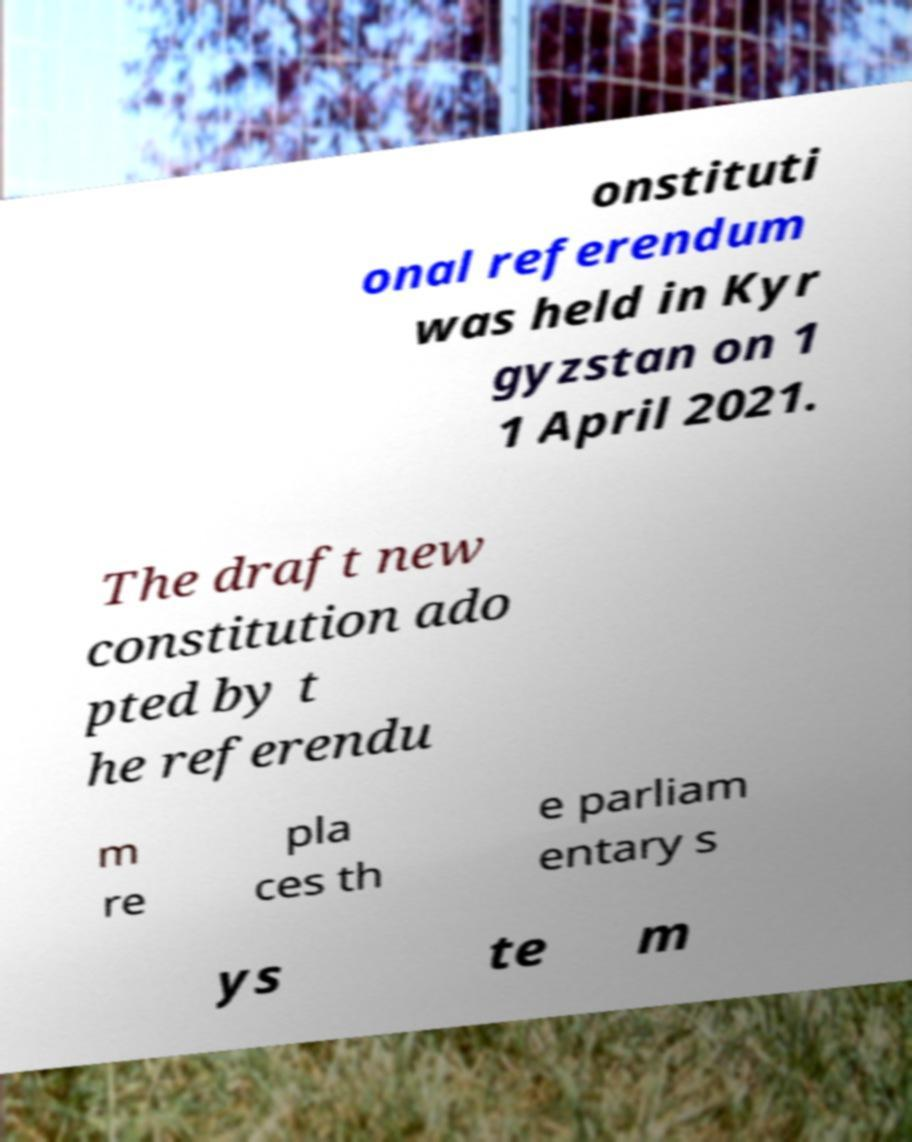What messages or text are displayed in this image? I need them in a readable, typed format. onstituti onal referendum was held in Kyr gyzstan on 1 1 April 2021. The draft new constitution ado pted by t he referendu m re pla ces th e parliam entary s ys te m 